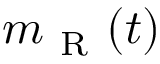Convert formula to latex. <formula><loc_0><loc_0><loc_500><loc_500>m _ { R } ( t )</formula> 